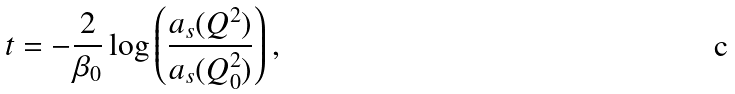Convert formula to latex. <formula><loc_0><loc_0><loc_500><loc_500>t = - { \frac { 2 } { \beta _ { 0 } } } \log \left ( { \frac { a _ { s } ( Q ^ { 2 } ) } { a _ { s } ( Q _ { 0 } ^ { 2 } ) } } \right ) ,</formula> 